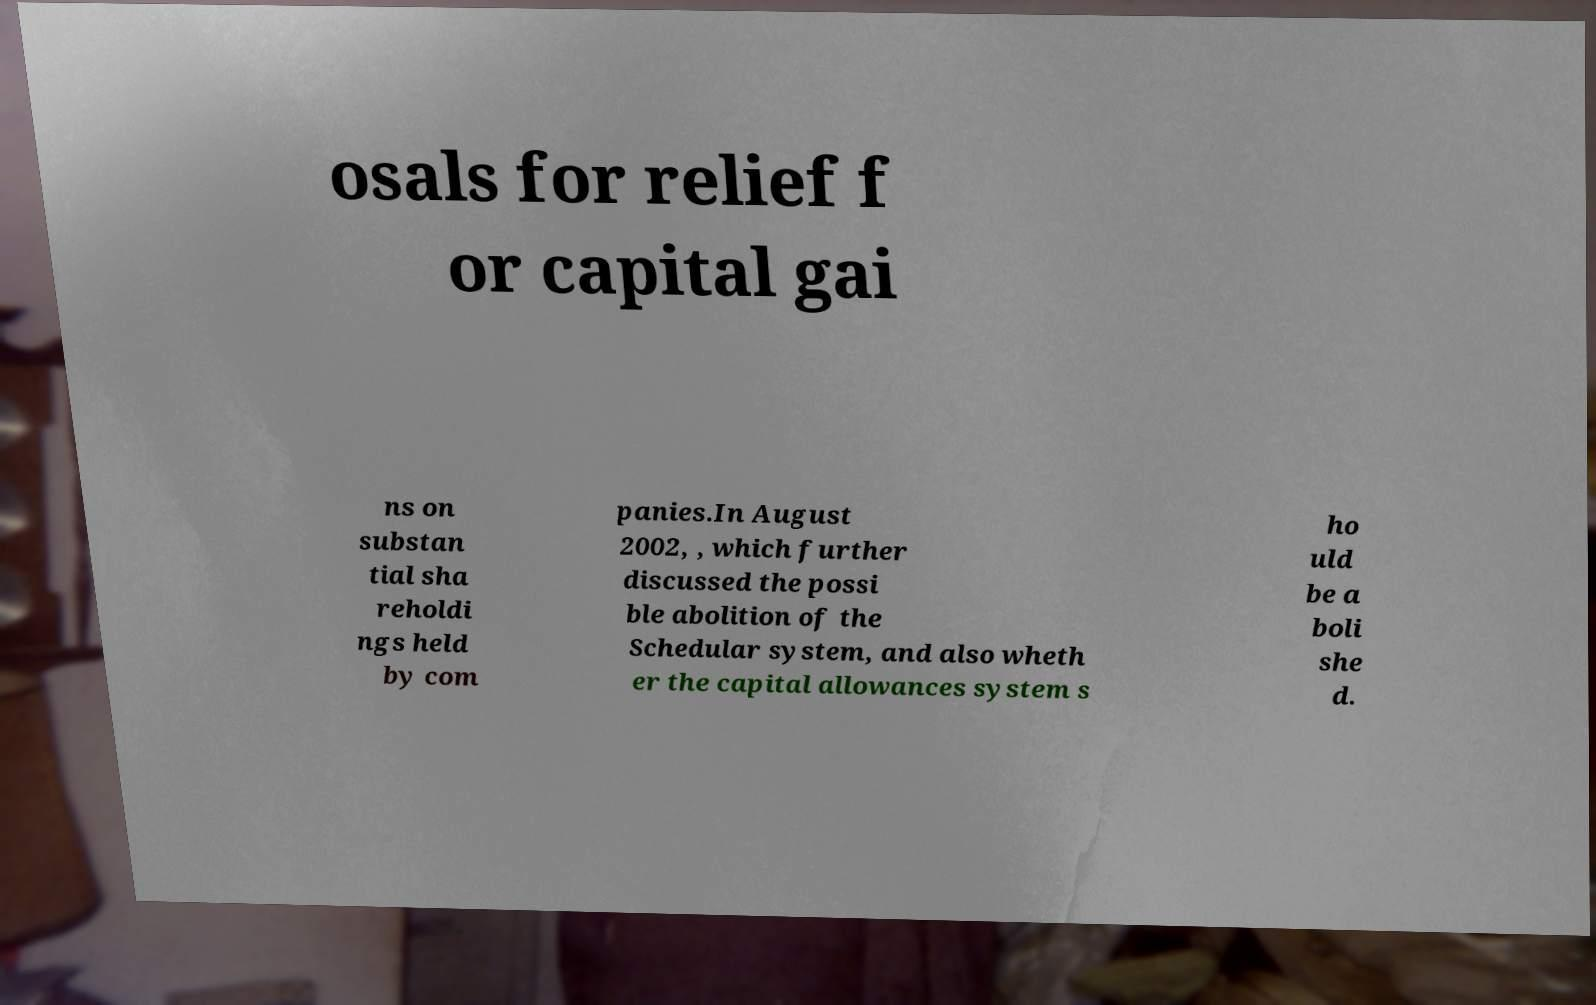There's text embedded in this image that I need extracted. Can you transcribe it verbatim? osals for relief f or capital gai ns on substan tial sha reholdi ngs held by com panies.In August 2002, , which further discussed the possi ble abolition of the Schedular system, and also wheth er the capital allowances system s ho uld be a boli she d. 